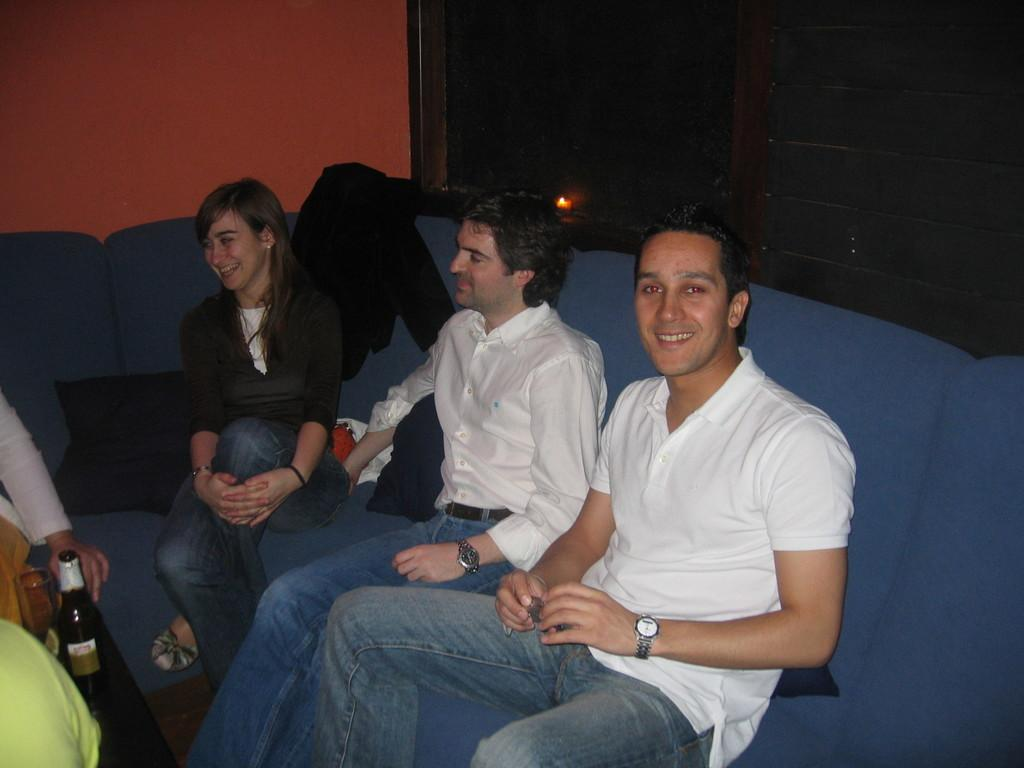What are the people in the image doing? The people in the image are seated on the sofa. Can you describe the beverage being held in the image? A human hand is holding a beer bottle in the image. What other object can be seen in the image? There is a glass visible in the image. What is located on the back of the sofa? Clothes are present on the back of the sofa in the image. How are the people in the image feeling? The people in the image have smiles on their faces, indicating that they are happy or enjoying themselves. What type of condition is being requested by the people in the image? There is no mention of a condition or request in the image; it simply shows people seated on a sofa with a beer bottle and a glass. 